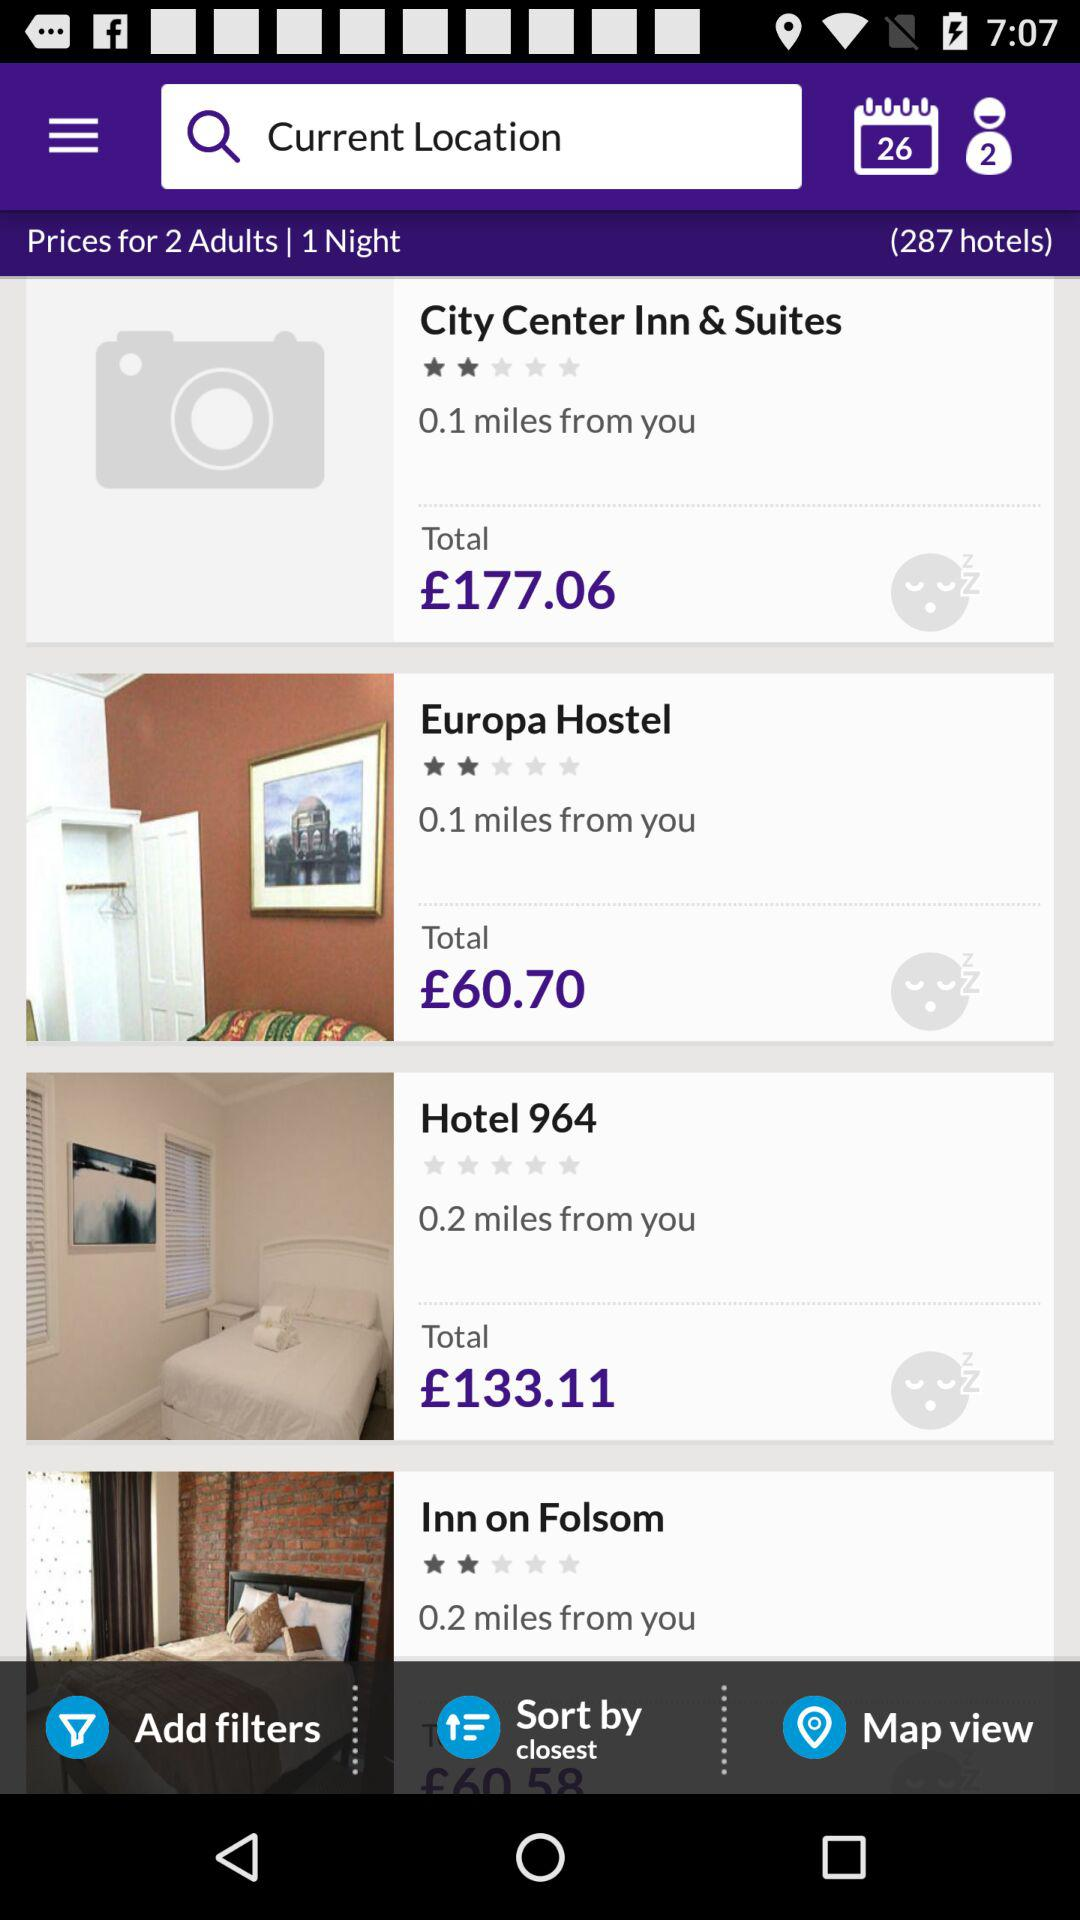How much is the cheapest hotel?
Answer the question using a single word or phrase. £60.70 